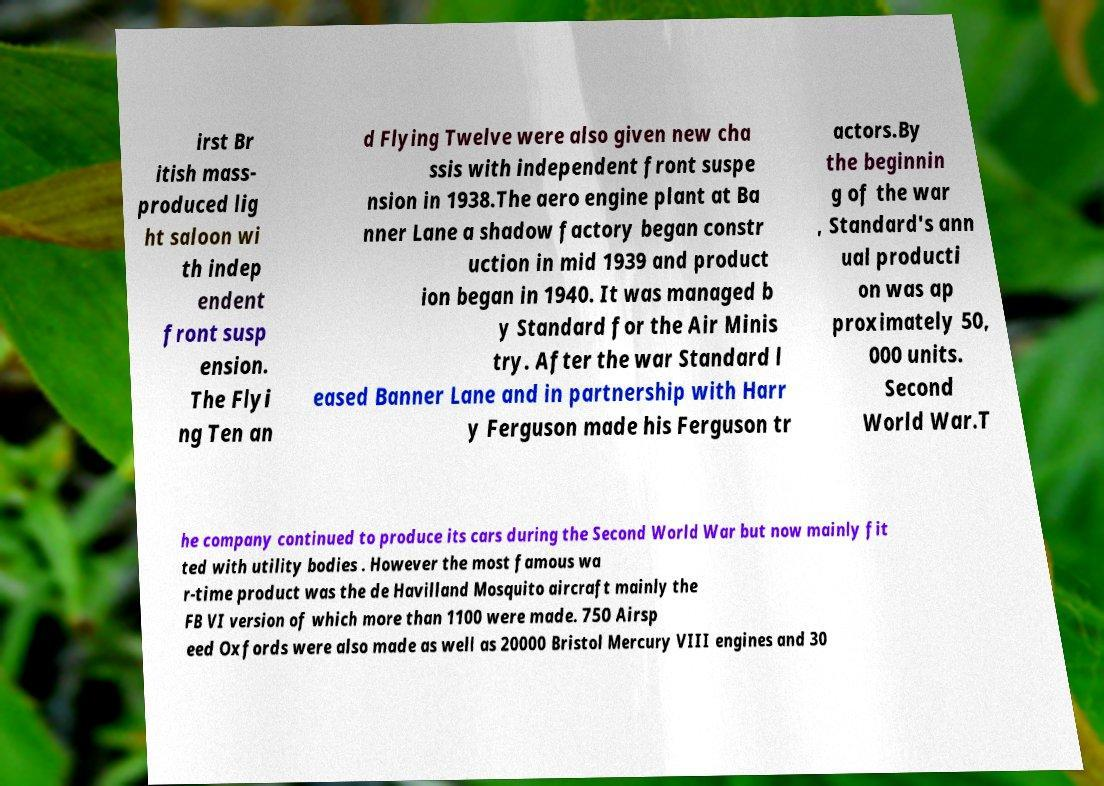What messages or text are displayed in this image? I need them in a readable, typed format. irst Br itish mass- produced lig ht saloon wi th indep endent front susp ension. The Flyi ng Ten an d Flying Twelve were also given new cha ssis with independent front suspe nsion in 1938.The aero engine plant at Ba nner Lane a shadow factory began constr uction in mid 1939 and product ion began in 1940. It was managed b y Standard for the Air Minis try. After the war Standard l eased Banner Lane and in partnership with Harr y Ferguson made his Ferguson tr actors.By the beginnin g of the war , Standard's ann ual producti on was ap proximately 50, 000 units. Second World War.T he company continued to produce its cars during the Second World War but now mainly fit ted with utility bodies . However the most famous wa r-time product was the de Havilland Mosquito aircraft mainly the FB VI version of which more than 1100 were made. 750 Airsp eed Oxfords were also made as well as 20000 Bristol Mercury VIII engines and 30 